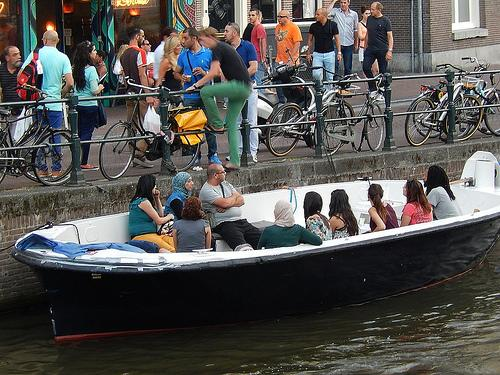Give a simple summary of the main elements in the image. People in a boat, bicycles leaning against a railing, and a man climbing over the railing are the main elements of the image. Briefly describe the primary elements and setting of the picture. The image shows a group of people in a boat, bicycles on a walkway, and a man climbing a railing near a brick wall and murky water. Narrate the interactions between the subjects in the image. People in a boat are watching others with bicycles on the walkway, while a man climbs over the railing to reach them or the boat. Provide a brief description of the central scene in the image. A group of people is sitting in a black and white boat on murky water near a brick retaining wall, while others with bicycles interact nearby. Describe the atmosphere and environment depicted in the image. The image has a casual, outdoor atmosphere with people in the boat and others with bikes near murky water and a brick retaining wall. Mention some of the prominent colors and objects in the image. Notable objects include a black and white boat, bicycles, and murky water, with colors like green pants, yellow pants, and a red brick wall. Describe a unique feature of the image. A man is climbing over a long metal railing, close to people sitting in a boat on the water and others with bicycles on a walkway. Write a sentence describing an action taking place in the image. A man in green pants is climbing over a railing near bicycles and a boat with several people sitting in it. Can you spot the beautiful white swans swimming next to the boat? There are no white swans mentioned in the image information. Observe the bright pink scooter parked near the motor scooter. There is only a mention of a motor scooter, but no bright pink scooter in the image information. Take note of the elderly man with a walking stick sitting on a bench. There is no elderly man or bench mentioned in the image information. Find the woman wearing a red dress standing next to the bicycle. There is no woman wearing a red dress in the given image information. Can you see the group of children playing football in the park? There are no children playing football mentioned in the image information. Admire the beautiful clear blue water surrounding the boat. The water in the image is described as "murky colored water," not clear blue. Isn't it interesting that the woman in the yellow pants is riding a skateboard? Although there is a woman wearing yellow pants, there is no mention of her riding a skateboard. Watch as the person in the bright orange hat waves to the people on the boat. There is no person with a bright orange hat in the given image information. Look for the dog playing with a frisbee in the open space. There is no dog or frisbee mentioned in the image information. Check out the lovely tall trees creating a green canopy over the scene. There are no tall trees or green canopy mentioned in the image information. 